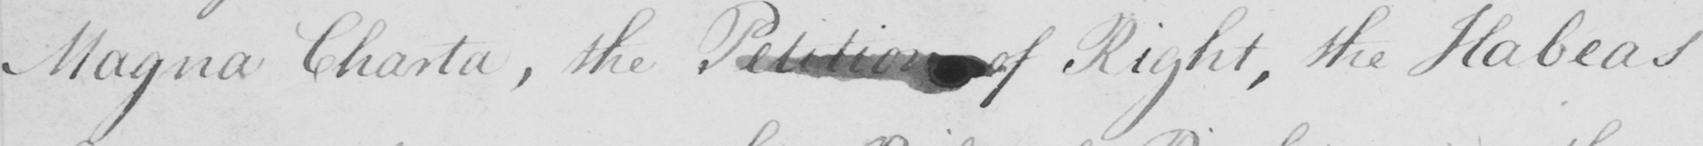Transcribe the text shown in this historical manuscript line. Magna Charta , the Petition of Right , the Habeas 